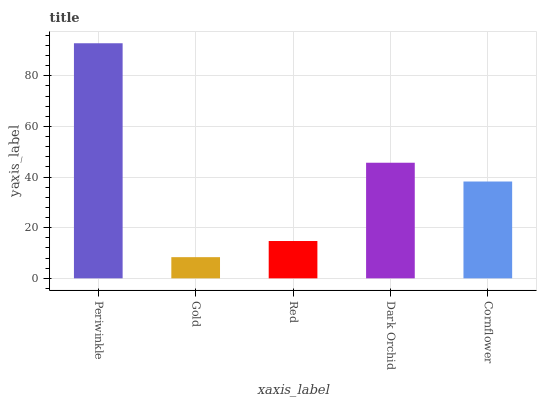Is Gold the minimum?
Answer yes or no. Yes. Is Periwinkle the maximum?
Answer yes or no. Yes. Is Red the minimum?
Answer yes or no. No. Is Red the maximum?
Answer yes or no. No. Is Red greater than Gold?
Answer yes or no. Yes. Is Gold less than Red?
Answer yes or no. Yes. Is Gold greater than Red?
Answer yes or no. No. Is Red less than Gold?
Answer yes or no. No. Is Cornflower the high median?
Answer yes or no. Yes. Is Cornflower the low median?
Answer yes or no. Yes. Is Periwinkle the high median?
Answer yes or no. No. Is Dark Orchid the low median?
Answer yes or no. No. 